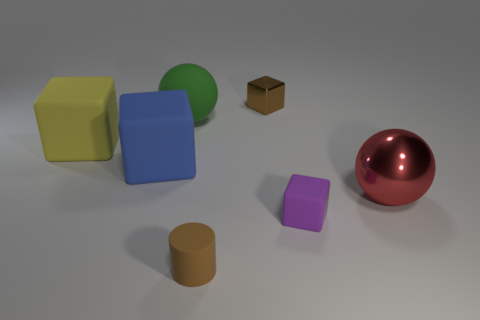There is a matte object that is to the right of the brown thing behind the big ball that is behind the blue matte thing; how big is it?
Your answer should be compact. Small. What number of shiny objects are either small purple blocks or small red balls?
Provide a succinct answer. 0. Does the big yellow rubber thing have the same shape as the small brown object to the right of the tiny brown cylinder?
Your response must be concise. Yes. Is the number of spheres that are in front of the blue object greater than the number of tiny rubber objects that are right of the red object?
Keep it short and to the point. Yes. Is there any other thing of the same color as the small metal object?
Offer a terse response. Yes. Is there a large ball to the right of the matte thing that is in front of the tiny rubber object that is to the right of the brown matte cylinder?
Your answer should be compact. Yes. Does the small brown object that is in front of the blue rubber object have the same shape as the purple rubber thing?
Your answer should be very brief. No. Is the number of tiny purple blocks to the right of the red shiny ball less than the number of brown blocks that are right of the tiny metallic thing?
Make the answer very short. No. What material is the purple thing?
Offer a very short reply. Rubber. There is a large shiny ball; is it the same color as the rubber object that is behind the yellow object?
Offer a very short reply. No. 